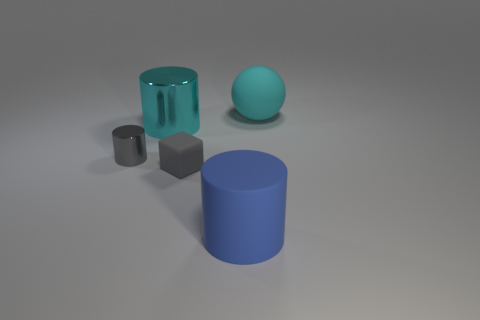Subtract all rubber cylinders. How many cylinders are left? 2 Add 2 rubber cubes. How many objects exist? 7 Subtract all cylinders. How many objects are left? 2 Add 3 small gray metal cylinders. How many small gray metal cylinders exist? 4 Subtract 0 brown balls. How many objects are left? 5 Subtract all green cylinders. Subtract all yellow blocks. How many cylinders are left? 3 Subtract all cylinders. Subtract all gray cylinders. How many objects are left? 1 Add 4 big spheres. How many big spheres are left? 5 